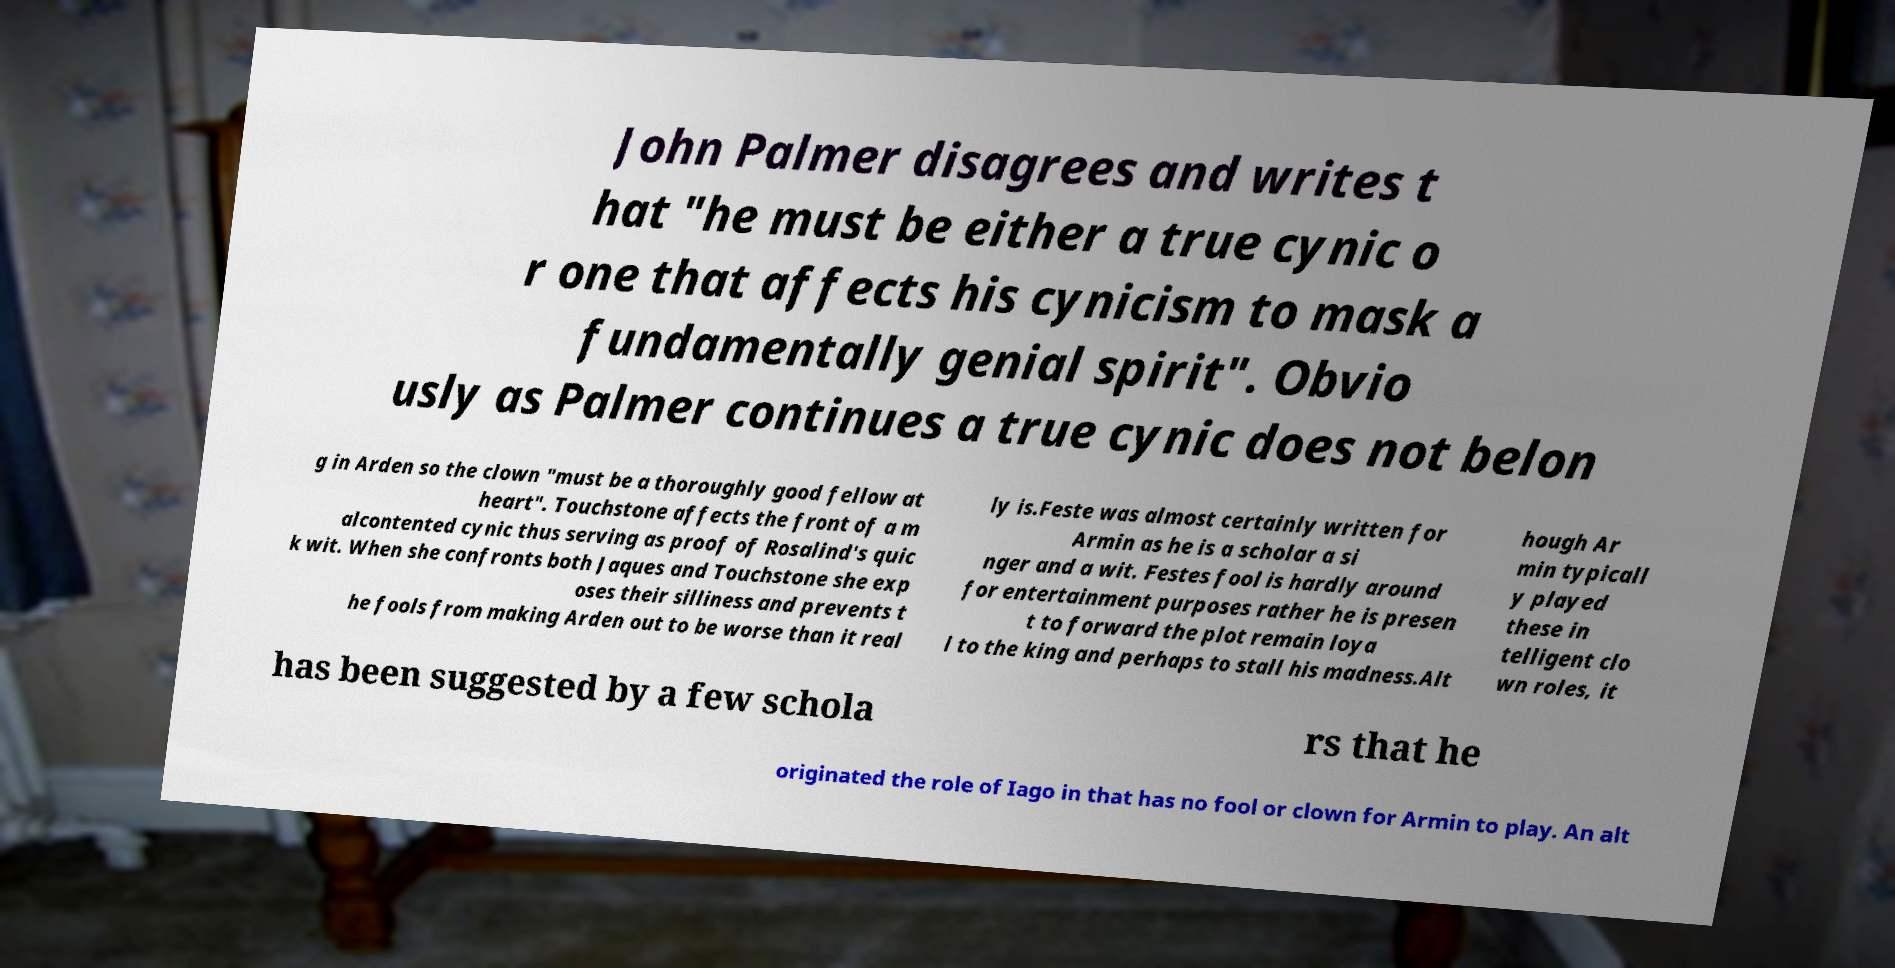Can you accurately transcribe the text from the provided image for me? John Palmer disagrees and writes t hat "he must be either a true cynic o r one that affects his cynicism to mask a fundamentally genial spirit". Obvio usly as Palmer continues a true cynic does not belon g in Arden so the clown "must be a thoroughly good fellow at heart". Touchstone affects the front of a m alcontented cynic thus serving as proof of Rosalind's quic k wit. When she confronts both Jaques and Touchstone she exp oses their silliness and prevents t he fools from making Arden out to be worse than it real ly is.Feste was almost certainly written for Armin as he is a scholar a si nger and a wit. Festes fool is hardly around for entertainment purposes rather he is presen t to forward the plot remain loya l to the king and perhaps to stall his madness.Alt hough Ar min typicall y played these in telligent clo wn roles, it has been suggested by a few schola rs that he originated the role of Iago in that has no fool or clown for Armin to play. An alt 